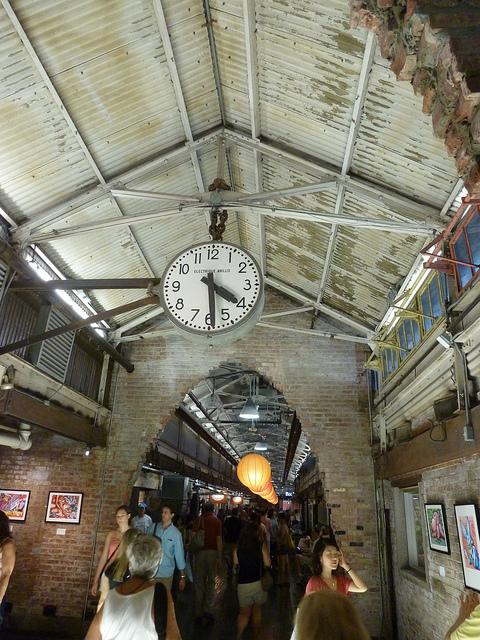What time is it approximately?

Choices:
A) 225
B) 915
C) 430
D) 637 430 